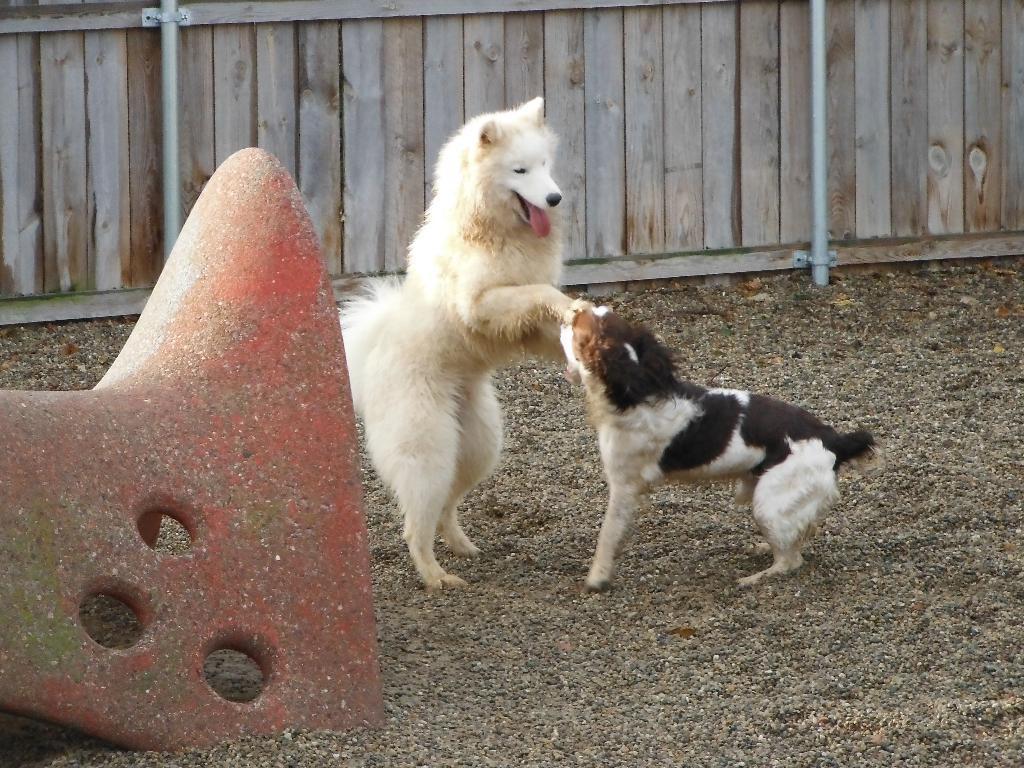Can you describe this image briefly? In this picture I can see two dogs are standing on the ground. The dog on the left side is white in color. In the background I can see a wooden wall which has two white color pipes attached to it. On the right side I can see a red color object on the ground. 